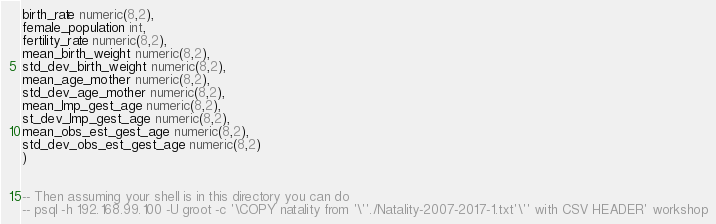Convert code to text. <code><loc_0><loc_0><loc_500><loc_500><_SQL_>birth_rate numeric(8,2),
female_population int,
fertility_rate numeric(8,2),
mean_birth_weight numeric(8,2),
std_dev_birth_weight numeric(8,2),
mean_age_mother numeric(8,2),
std_dev_age_mother numeric(8,2),
mean_lmp_gest_age numeric(8,2),
st_dev_lmp_gest_age numeric(8,2),
mean_obs_est_gest_age numeric(8,2),
std_dev_obs_est_gest_age numeric(8,2)
)


-- Then assuming your shell is in this directory you can do
-- psql -h 192.168.99.100 -U groot -c '\COPY natality from '\''./Natality-2007-2017-1.txt'\'' with CSV HEADER' workshop</code> 